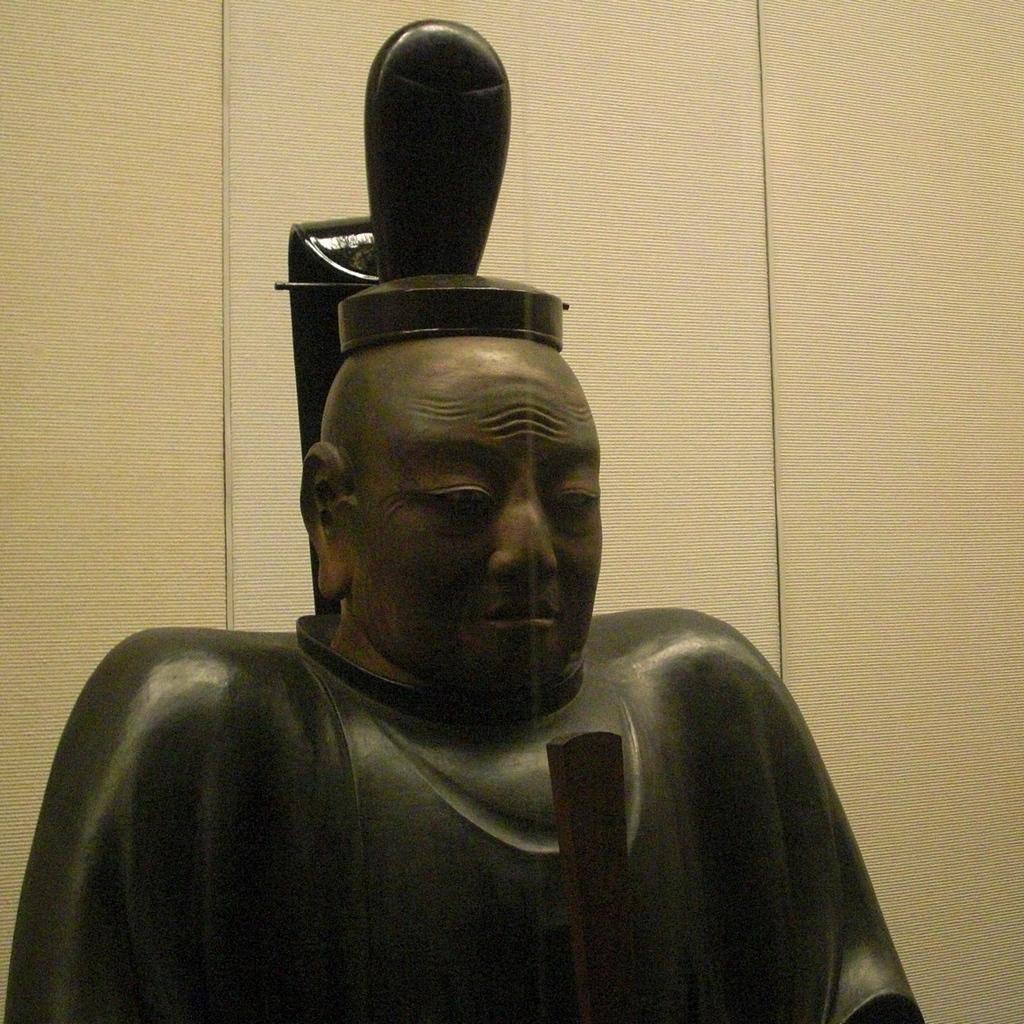What is the main subject in the image? There is a statue in the image. Can you describe the setting of the image? There is a wall in the background of the image. What type of cakes are being served at the nation's celebration in the image? There is no mention of a nation or celebration in the image, nor are there any cakes present. 